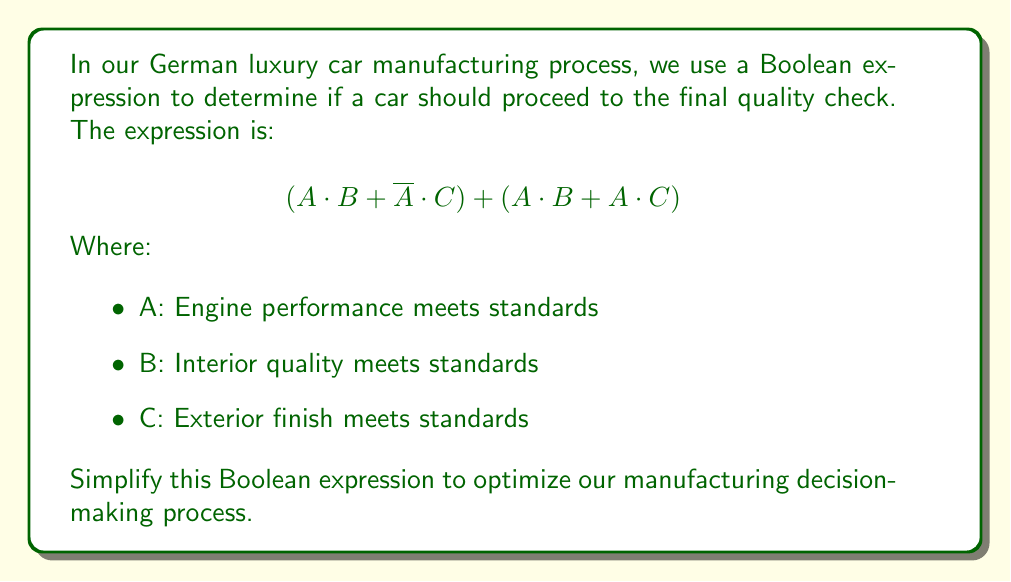Can you answer this question? Let's simplify this Boolean expression step by step:

1) First, let's distribute A over (B + C) in the second term:
   $$(A \cdot B + \overline{A} \cdot C) + (A \cdot B + A \cdot C)$$
   $$= (A \cdot B + \overline{A} \cdot C) + A \cdot (B + C)$$

2) Now, we can use the distributive law to factor out A·B:
   $$= A \cdot B + \overline{A} \cdot C + A \cdot B + A \cdot C$$
   $$= (A \cdot B + A \cdot B) + (\overline{A} \cdot C + A \cdot C)$$

3) Simplify the repeated term A·B:
   $$= A \cdot B + (\overline{A} \cdot C + A \cdot C)$$

4) The term $(\overline{A} \cdot C + A \cdot C)$ can be simplified using the distributive law:
   $$= A \cdot B + (\overline{A} + A) \cdot C$$

5) $(\overline{A} + A)$ is always true (1 in Boolean algebra), so:
   $$= A \cdot B + 1 \cdot C$$
   $$= A \cdot B + C$$

This simplified expression means that a car should proceed to final quality check if either:
- Both engine performance (A) and interior quality (B) meet standards, or
- The exterior finish (C) meets standards (regardless of A and B)
Answer: $$A \cdot B + C$$ 